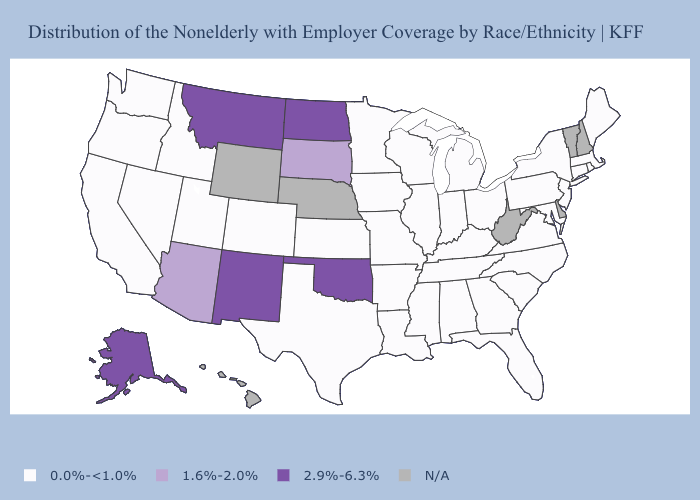Name the states that have a value in the range N/A?
Concise answer only. Delaware, Hawaii, Nebraska, New Hampshire, Vermont, West Virginia, Wyoming. Among the states that border Wisconsin , which have the highest value?
Be succinct. Illinois, Iowa, Michigan, Minnesota. Name the states that have a value in the range 1.6%-2.0%?
Quick response, please. Arizona, South Dakota. What is the value of Delaware?
Answer briefly. N/A. What is the value of North Carolina?
Answer briefly. 0.0%-<1.0%. Does North Dakota have the lowest value in the USA?
Quick response, please. No. Does Maryland have the highest value in the USA?
Quick response, please. No. Name the states that have a value in the range 1.6%-2.0%?
Be succinct. Arizona, South Dakota. What is the value of Arkansas?
Concise answer only. 0.0%-<1.0%. What is the lowest value in the West?
Short answer required. 0.0%-<1.0%. What is the value of South Dakota?
Concise answer only. 1.6%-2.0%. Does North Dakota have the lowest value in the USA?
Concise answer only. No. What is the lowest value in states that border Vermont?
Give a very brief answer. 0.0%-<1.0%. What is the value of Kansas?
Write a very short answer. 0.0%-<1.0%. What is the lowest value in states that border Rhode Island?
Short answer required. 0.0%-<1.0%. 